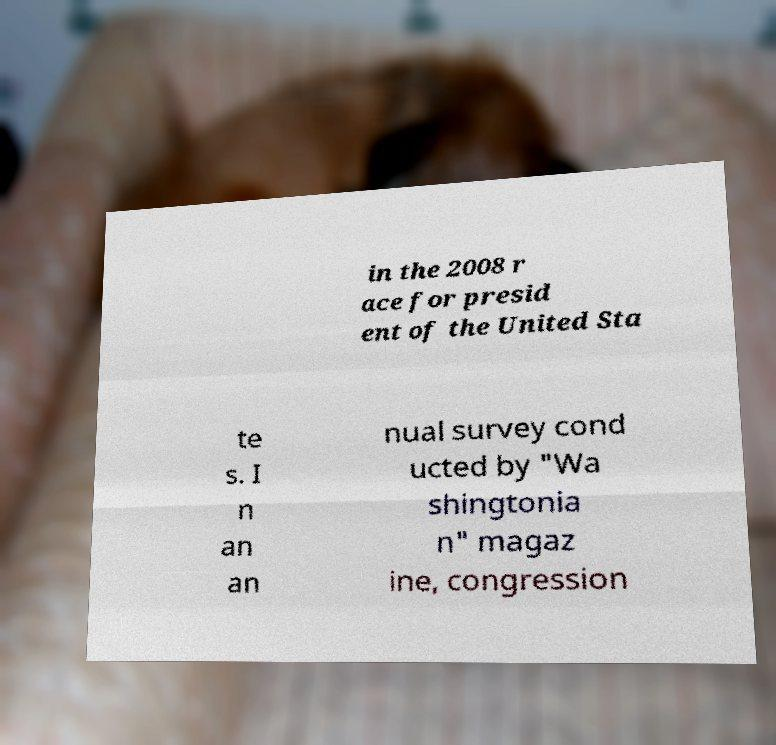Can you accurately transcribe the text from the provided image for me? in the 2008 r ace for presid ent of the United Sta te s. I n an an nual survey cond ucted by "Wa shingtonia n" magaz ine, congression 